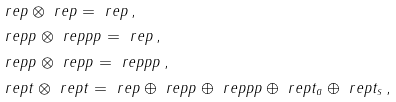<formula> <loc_0><loc_0><loc_500><loc_500>& \ r e p \otimes \ r e p = \ r e p \, , \\ & \ r e p p \otimes \ r e p p p = \ r e p \, , \\ & \ r e p p \otimes \ r e p p = \ r e p p p \, , \\ & \ r e p t \otimes \ r e p t = \ r e p \oplus \ r e p p \oplus \ r e p p p \oplus \ r e p t _ { a } \oplus \ r e p t _ { s } \, ,</formula> 